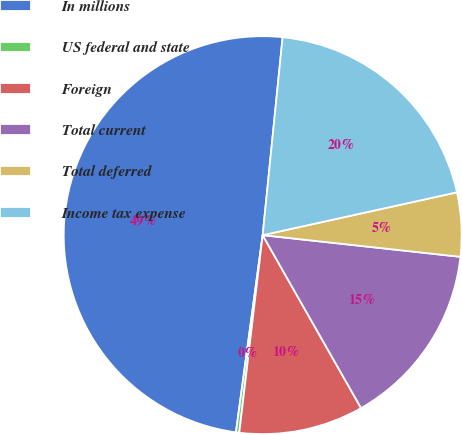Convert chart. <chart><loc_0><loc_0><loc_500><loc_500><pie_chart><fcel>In millions<fcel>US federal and state<fcel>Foreign<fcel>Total current<fcel>Total deferred<fcel>Income tax expense<nl><fcel>49.46%<fcel>0.27%<fcel>10.11%<fcel>15.03%<fcel>5.19%<fcel>19.95%<nl></chart> 